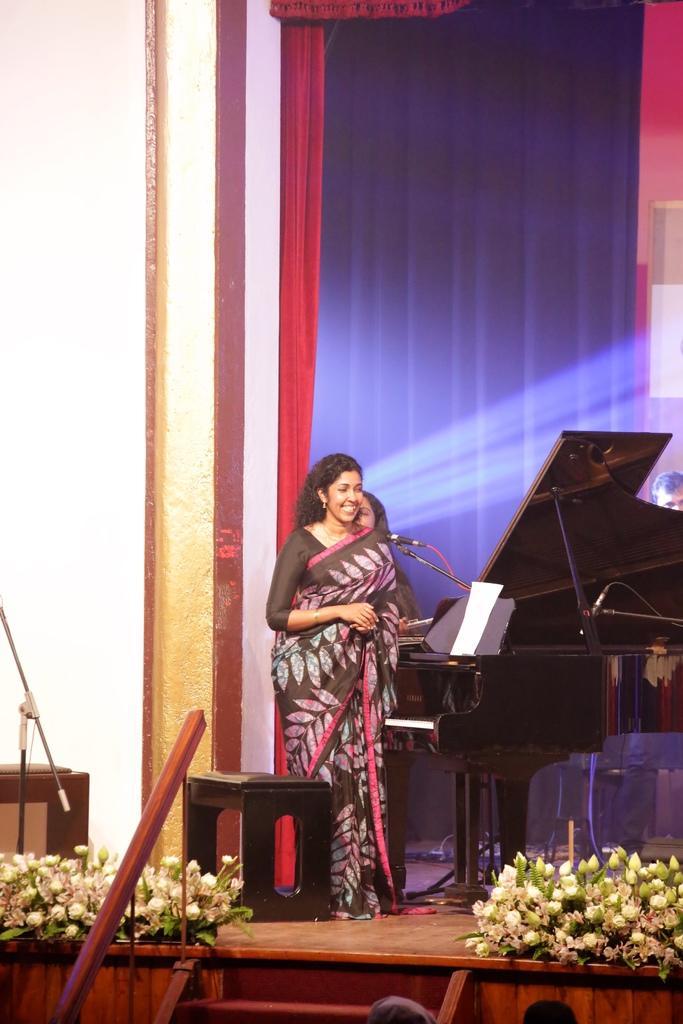How would you summarize this image in a sentence or two? In this image we can see three persons on the stage, there is a musical instrument, a stool, paper, mic, flowers, stairs and in the background there is curtain and a wall. 